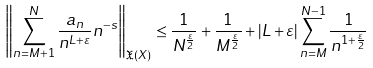<formula> <loc_0><loc_0><loc_500><loc_500>\left \| \sum _ { n = M + 1 } ^ { N } \frac { a _ { n } } { n ^ { L + \varepsilon } } n ^ { - s } \right \| _ { \mathfrak { X } ( X ) } \leq \frac { 1 } { N ^ { \frac { \varepsilon } { 2 } } } + \frac { 1 } { M ^ { \frac { \varepsilon } { 2 } } } + | L + \varepsilon | \sum _ { n = M } ^ { N - 1 } \frac { 1 } { n ^ { 1 + \frac { \varepsilon } { 2 } } } \,</formula> 